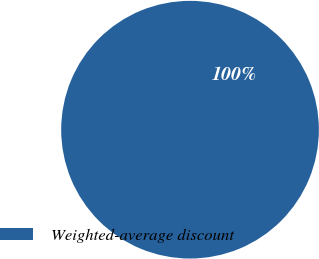Convert chart to OTSL. <chart><loc_0><loc_0><loc_500><loc_500><pie_chart><fcel>Weighted-average discount<nl><fcel>100.0%<nl></chart> 